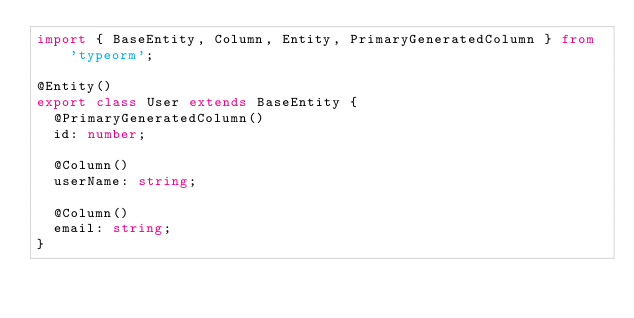<code> <loc_0><loc_0><loc_500><loc_500><_TypeScript_>import { BaseEntity, Column, Entity, PrimaryGeneratedColumn } from 'typeorm';

@Entity()
export class User extends BaseEntity {
  @PrimaryGeneratedColumn()
  id: number;

  @Column()
  userName: string;

  @Column()
  email: string;
}
</code> 